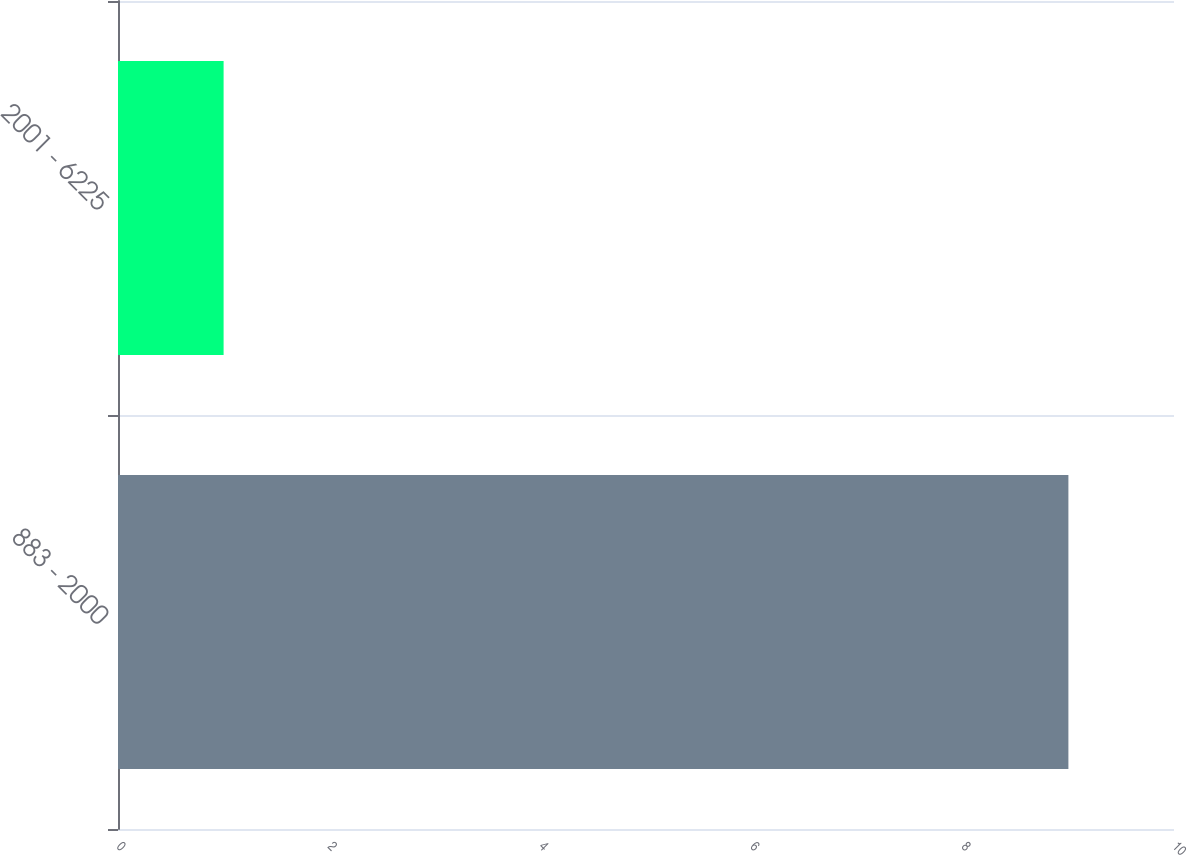Convert chart to OTSL. <chart><loc_0><loc_0><loc_500><loc_500><bar_chart><fcel>883 - 2000<fcel>2001 - 6225<nl><fcel>9<fcel>1<nl></chart> 